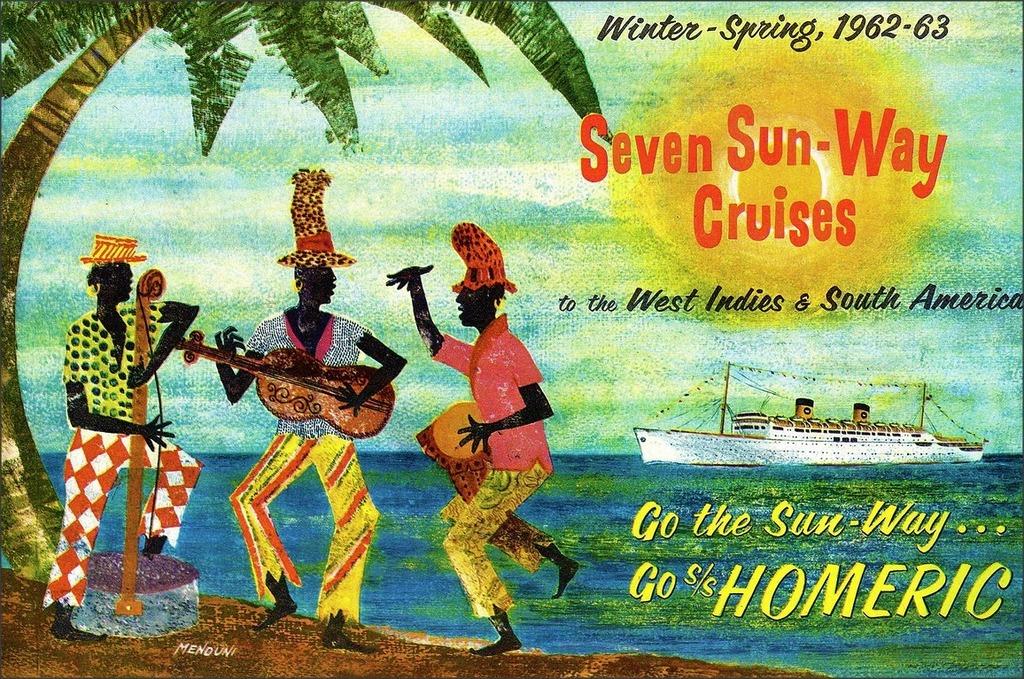Where does the cruise go to?
Give a very brief answer. West indies and south america. What year is this?
Your response must be concise. 1962-63. 